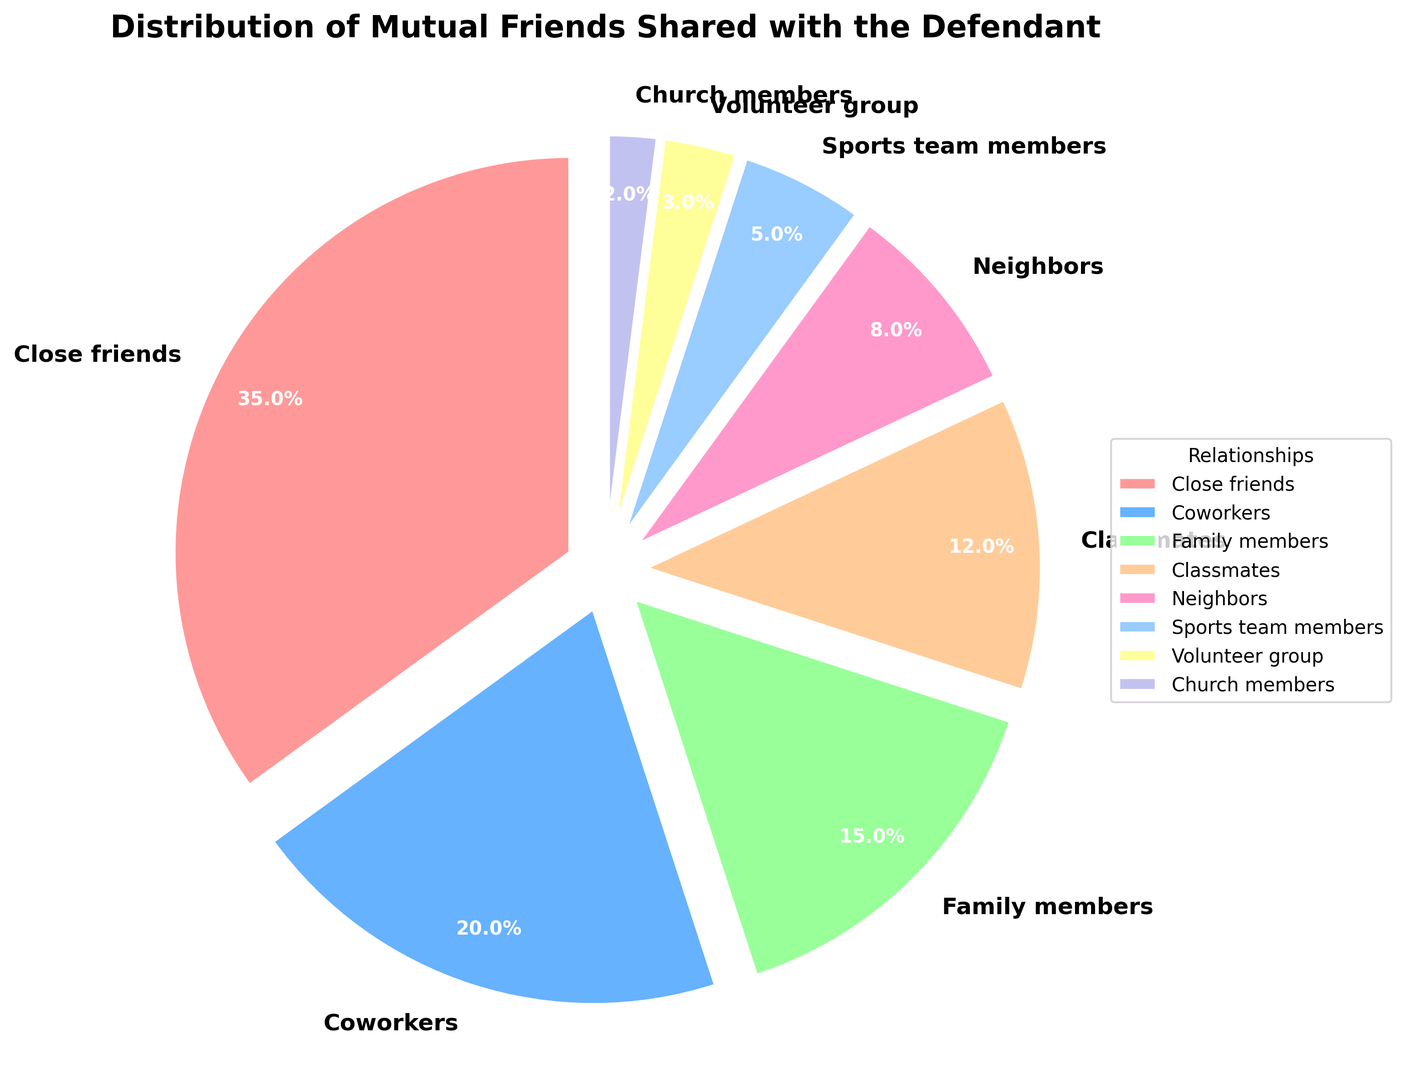Which category has the largest percentage of mutual friends shared with the defendant? The figure shows the percentage distribution of mutual friends shared with the defendant. The wedge representing 'Close friends' is the largest, indicating the highest percentage.
Answer: Close friends Which two categories combined account for more than half of the mutual friends? By adding the percentages of the top categories from the chart—Close friends (35%), Coworkers (20%)—we get 35% + 20% = 55%, which is more than half of the total.
Answer: Close friends and Coworkers How much more significant is the 'Family members' category compared to the 'Church members' category? The percentage for Family members is 15%, and for Church members, it is 2%. The difference is calculated as 15% - 2% = 13%.
Answer: 13% Which two categories together make up exactly one-fifth of the mutual friends? One-fifth of the total 100% is 20%. The chart shows 'Classmates' with 12% and 'Neighbors' with 8%. Adding them gives 12% + 8% = 20%, making it exactly one-fifth.
Answer: Classmates and Neighbors Which category falls in the middle rank in terms of the number of mutual friends? When ordered by percentage, the categories from largest to smallest are: Close friends (35%), Coworkers (20%), Family members (15%), Classmates (12%), Neighbors (8%), Sports team members (5%), Volunteer group (3%), and Church members (2%). The middle-ranked category is 'Classmates' at 12%.
Answer: Classmates What is the total percentage of mutual friends that are either 'Sports team members' or 'Volunteer group'? According to the pie chart, the percentage for Sports team members is 5%, and for the Volunteer group, it is 3%. Summing these percentages, we get 5% + 3% = 8%.
Answer: 8% Is the percentage of mutual friends who are 'Family members' greater than those who are 'Classmates'? The figure indicates 'Family members' at 15% and 'Classmates' at 12%. Comparing these, 15% is greater than 12%.
Answer: Yes If the size of each wedge in the pie chart is directly proportional to the percentage, which wedge is expected to be the smallest? The smallest percentage category is 'Church members' with 2%. Thus, its wedge will be the smallest.
Answer: Church members Comparing 'Coworkers' and 'Neighbors', how much larger is the 'Coworkers' category? The percentage for Coworkers is 20%, while for Neighbors, it is 8%. The difference is calculated as 20% - 8% = 12%.
Answer: 12% What fraction of the total mutual friends is represented by 'Volunteer group' and 'Church members' combined? The pie chart shows percentages for Volunteer group (3%) and Church members (2%). Combined, this makes 3% + 2% = 5%, which is 5/100 or 1/20 in fractional form.
Answer: 1/20 